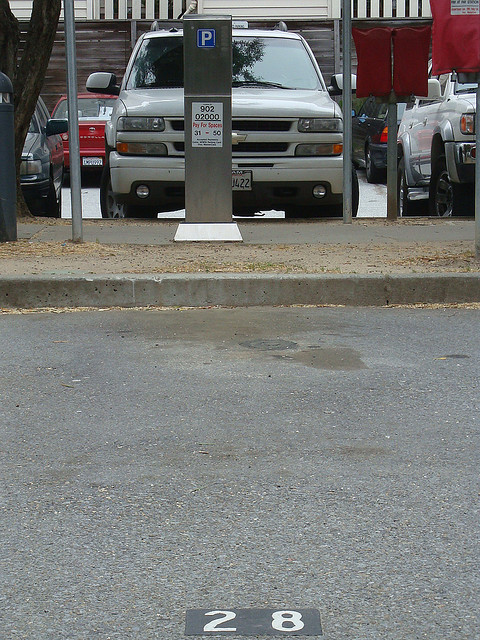Is this area equipped with sufficient parking spaces for peak hours? It appears from the image that parking could be challenging during peak hours. The presence of a meter indicates a structured yet potentially limited parking system, suggesting a high demand particularly during busy times. This would necessitate drivers arriving early or planning ahead to secure a spot. What alternative actions can a driver take if they can't find a parking spot here? If a driver cannot find a parking spot, they may consider nearby parking facilities, such as parking garages or lots, which might have more availability. Utilizing public transportation or ride-sharing services could also be viable alternatives to avoid parking challenges altogether. Additionally, one could use parking apps to find and reserve available spots ahead of time. Can the local authorities implement any measures to improve the parking situation? Local authorities could explore several measures to enhance the parking situation. Introducing dynamic pricing could optimize parking space usage, while investment in parking guidance systems could direct drivers efficiently to available spots. Additionally, expanding public transportation options or establishing satellite parking areas with shuttle services could alleviate parking demand in congested areas. 